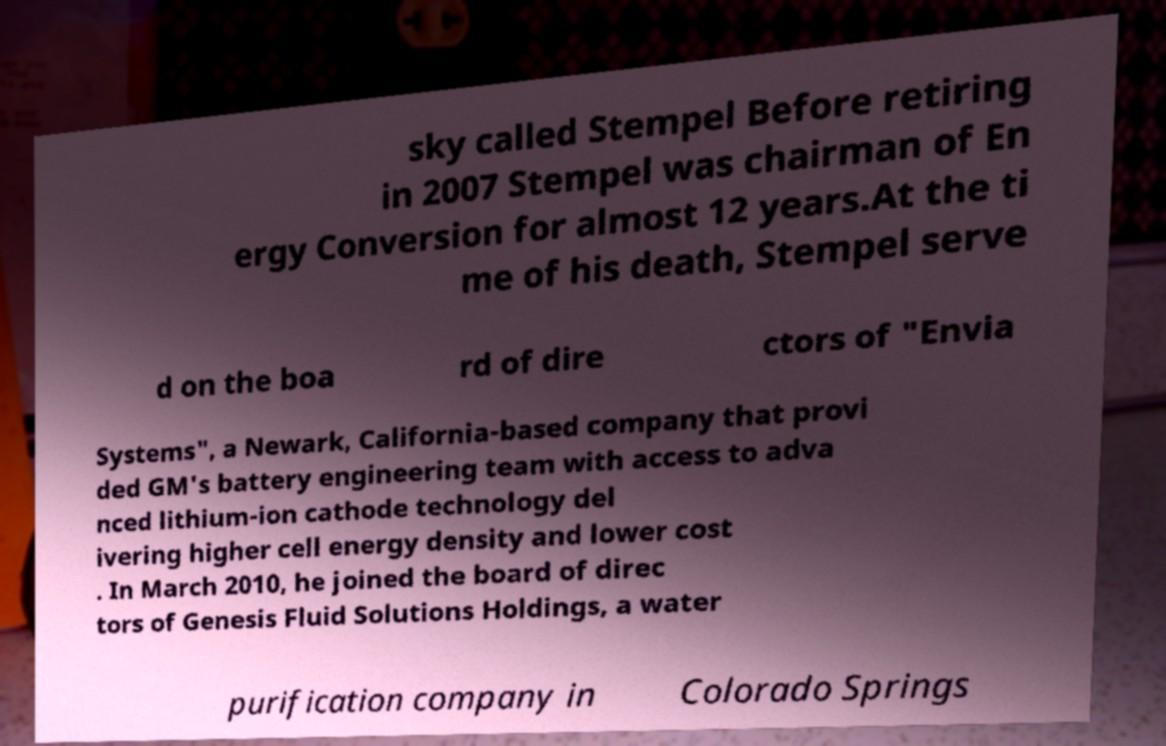Can you read and provide the text displayed in the image?This photo seems to have some interesting text. Can you extract and type it out for me? sky called Stempel Before retiring in 2007 Stempel was chairman of En ergy Conversion for almost 12 years.At the ti me of his death, Stempel serve d on the boa rd of dire ctors of "Envia Systems", a Newark, California-based company that provi ded GM's battery engineering team with access to adva nced lithium-ion cathode technology del ivering higher cell energy density and lower cost . In March 2010, he joined the board of direc tors of Genesis Fluid Solutions Holdings, a water purification company in Colorado Springs 